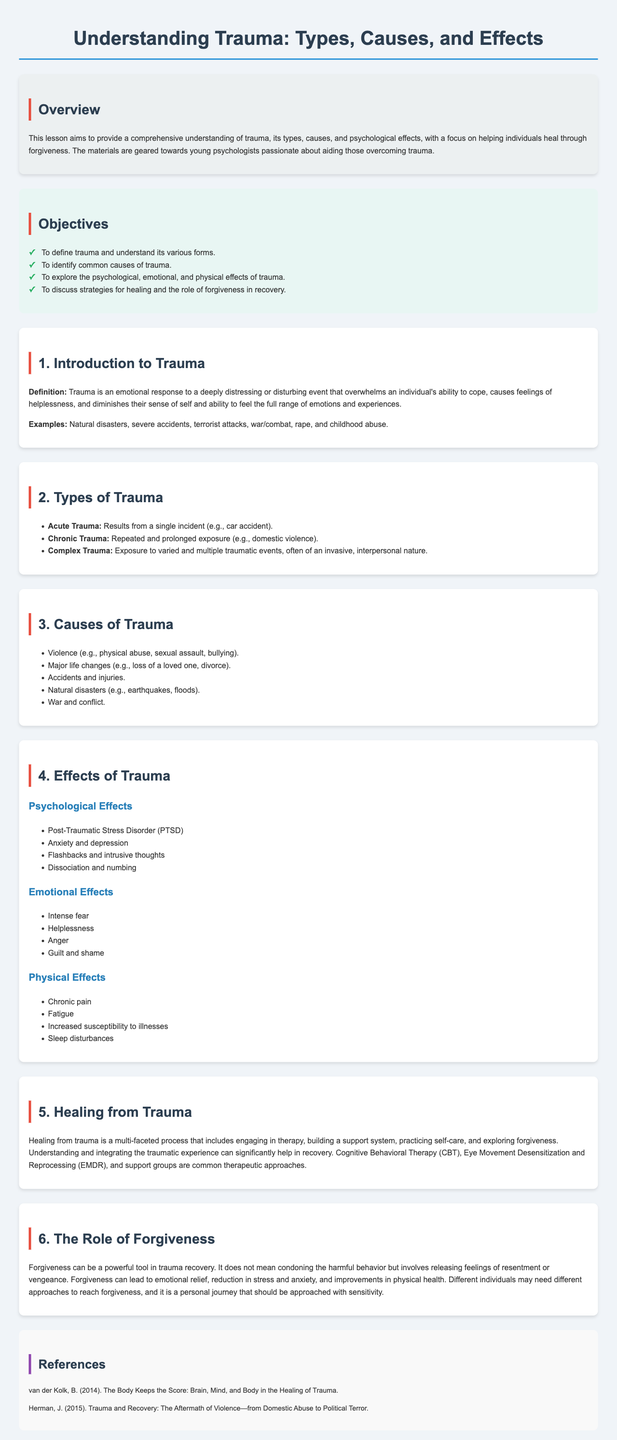What is the title of the lesson plan? The title of the lesson plan is found in the heading at the top of the document.
Answer: Understanding Trauma: Types, Causes, and Effects What are the three types of trauma mentioned? The document lists three types of trauma under the section titled "Types of Trauma."
Answer: Acute Trauma, Chronic Trauma, Complex Trauma What major life changes can cause trauma? The document specifies major life changes that can be a cause of trauma under the "Causes of Trauma" section.
Answer: Loss of a loved one, divorce What psychological effect is associated with trauma? The document discusses psychological effects of trauma in the "Effects of Trauma" section.
Answer: Post-Traumatic Stress Disorder (PTSD) What is one strategy for healing from trauma? The "Healing from Trauma" section lists approaches for recovery, including therapeutic methods.
Answer: Therapy What role does forgiveness play in trauma recovery? The document explores the concept of forgiveness in relation to trauma recovery in the section titled "The Role of Forgiveness."
Answer: A powerful tool How many objectives are listed in the objectives section? The objectives section in the document outlines specific goals for the lesson.
Answer: Four What is the name of a book referenced in the document? The references section lists notable books related to trauma recovery.
Answer: The Body Keeps the Score: Brain, Mind, and Body in the Healing of Trauma What type of document is this? The structure and content presented in the document suggest its purpose.
Answer: Lesson plan 